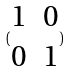Convert formula to latex. <formula><loc_0><loc_0><loc_500><loc_500>( \begin{matrix} 1 & 0 \\ 0 & 1 \end{matrix} )</formula> 